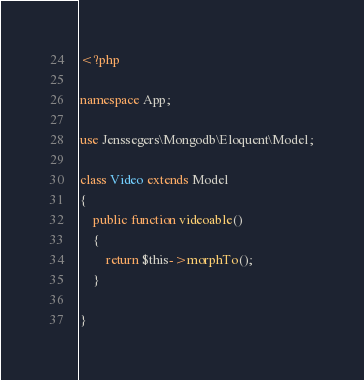<code> <loc_0><loc_0><loc_500><loc_500><_PHP_><?php

namespace App;

use Jenssegers\Mongodb\Eloquent\Model;

class Video extends Model
{
	public function videoable()
	{
		return $this->morphTo();
	}
    
}
</code> 